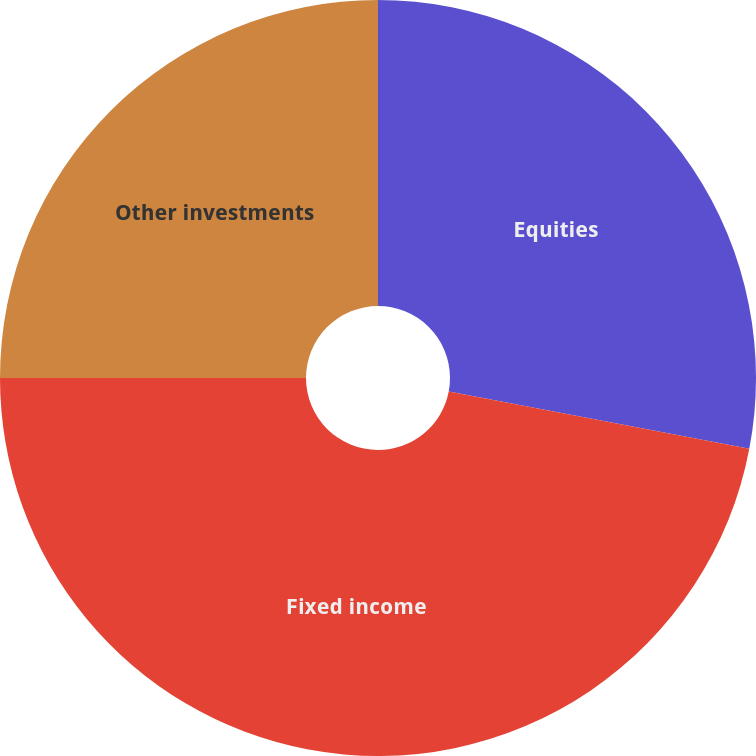<chart> <loc_0><loc_0><loc_500><loc_500><pie_chart><fcel>Equities<fcel>Fixed income<fcel>Other investments<nl><fcel>28.0%<fcel>47.0%<fcel>25.0%<nl></chart> 